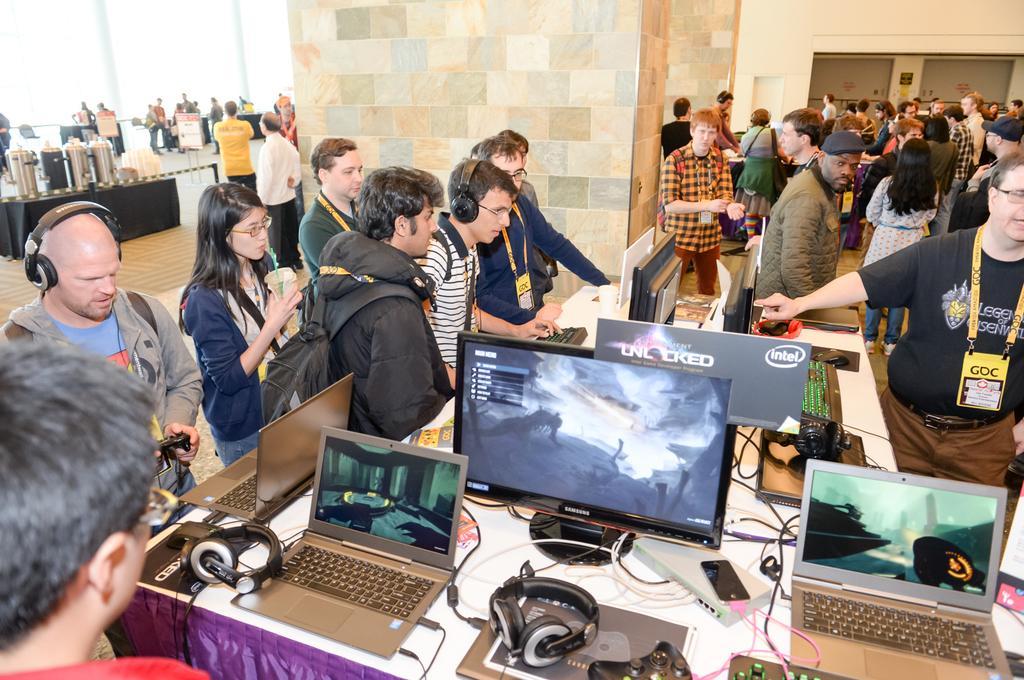Can you describe this image briefly? In this image there are so many people standing on the hall, beside them there is a table with laptops and desk tops, also there is a pillar and elevators and there is a table with some cans on it. 